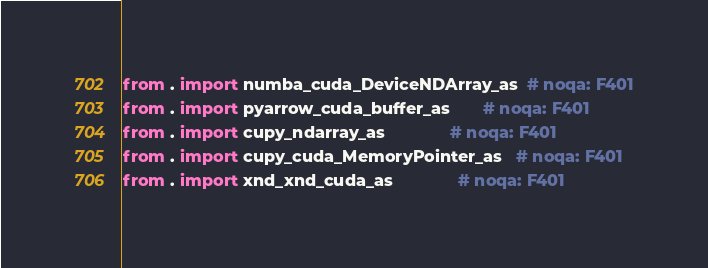<code> <loc_0><loc_0><loc_500><loc_500><_Python_>
from . import numba_cuda_DeviceNDArray_as  # noqa: F401
from . import pyarrow_cuda_buffer_as       # noqa: F401
from . import cupy_ndarray_as              # noqa: F401
from . import cupy_cuda_MemoryPointer_as   # noqa: F401
from . import xnd_xnd_cuda_as              # noqa: F401</code> 